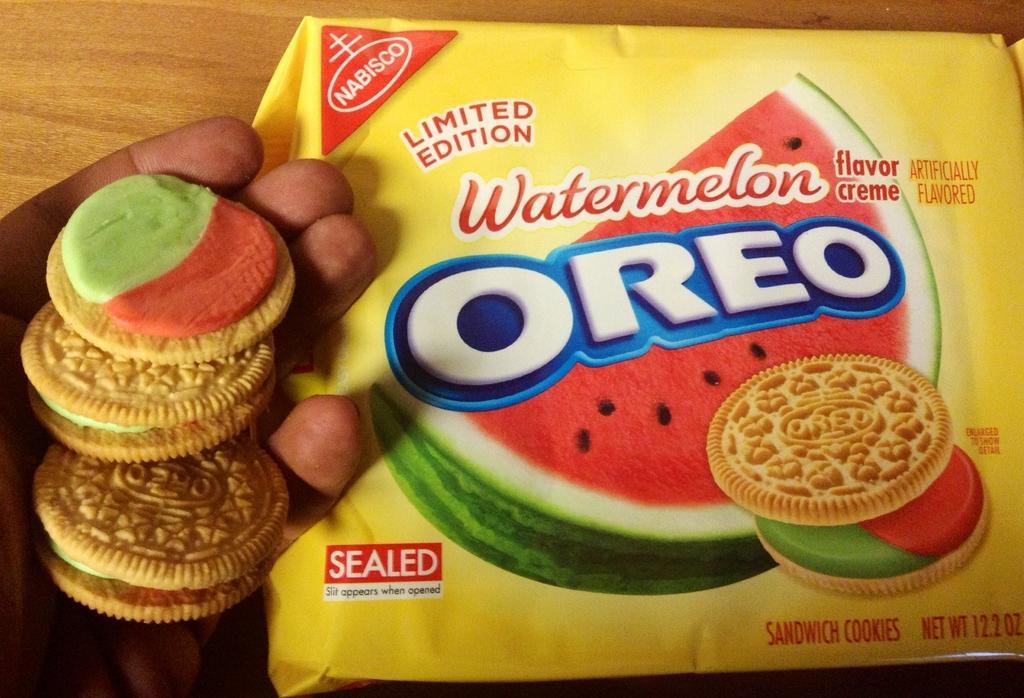How would you summarize this image in a sentence or two? In this picture we can see a person's hand who is holding cream biscuits. Beside him we can see a biscuit packet on the table. 